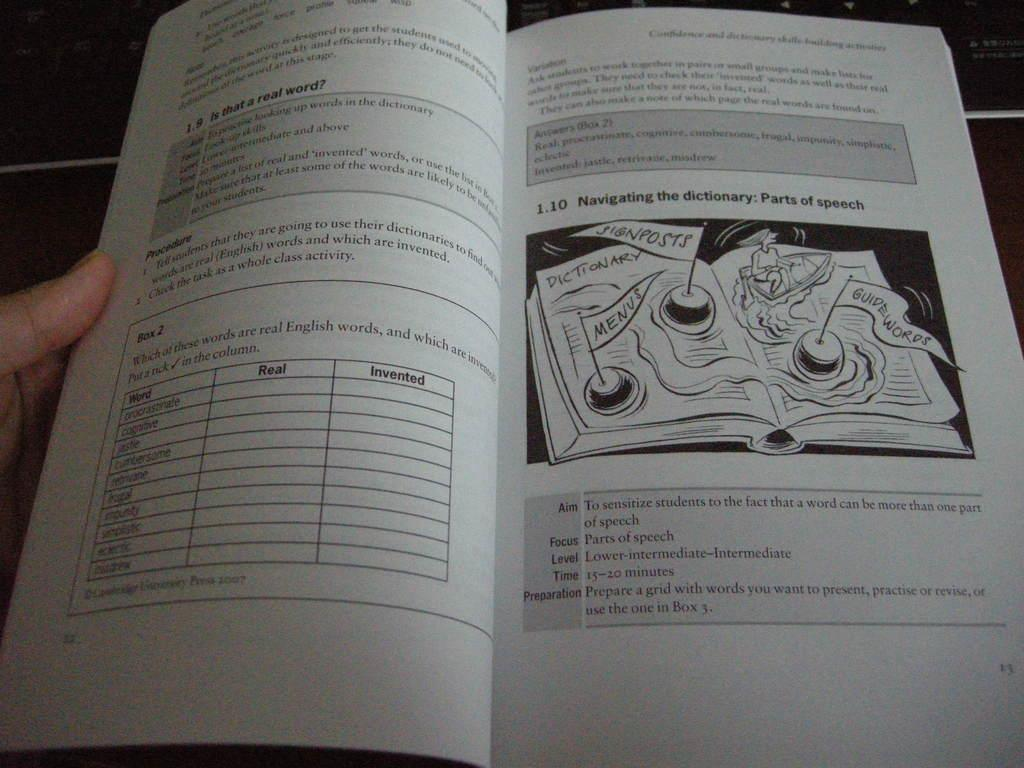<image>
Offer a succinct explanation of the picture presented. A book is opened to a section titled navigating the dictionary. 